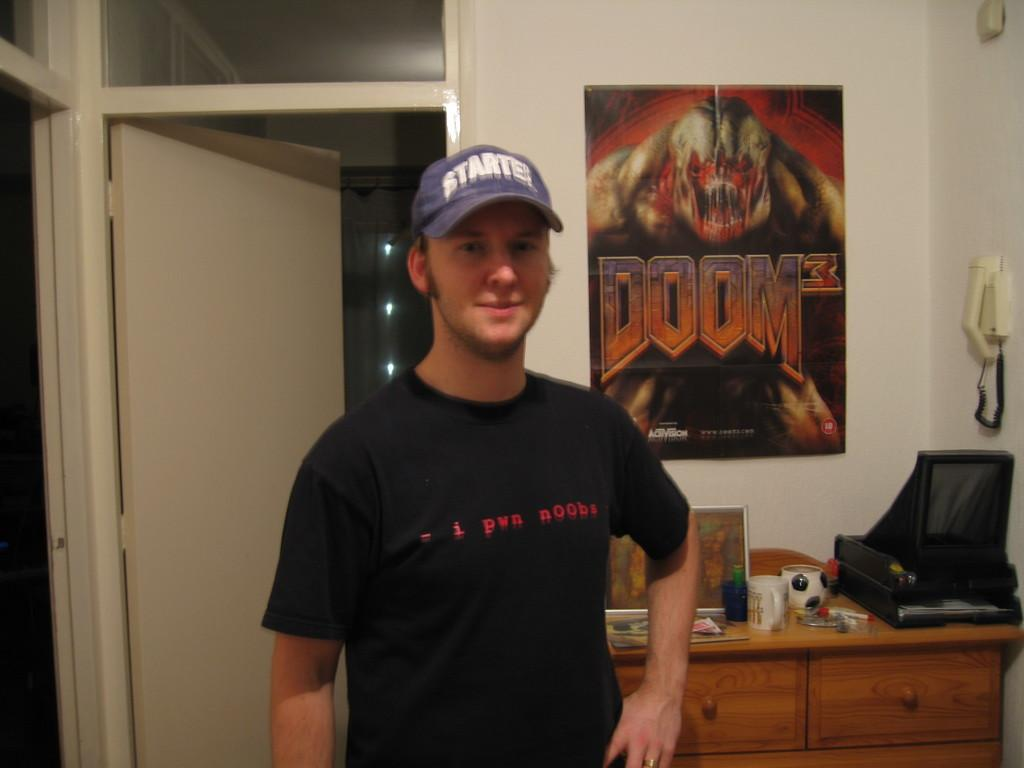<image>
Give a short and clear explanation of the subsequent image. A man stands in front of a Doom 3 poster. 